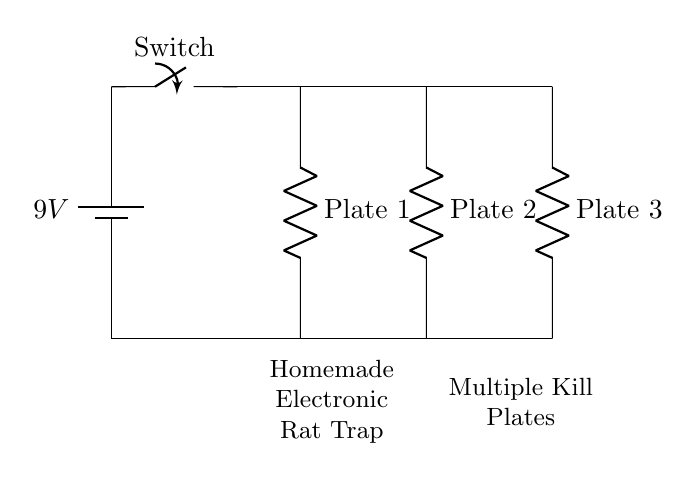What is the voltage of the power source? The voltage is labeled as 9V on the battery component in the circuit diagram, indicating the potential difference supplied to the circuit.
Answer: 9V How many kill plates are there in the circuit? There are three kill plates represented as resistors in the parallel configuration, which can be counted from left to right in the diagram.
Answer: Three What type of circuit is this? This circuit is a parallel circuit, as indicated by the configuration where multiple components (kill plates) are connected across the same two points of the power source, allowing for independent operation.
Answer: Parallel What is the role of the switch in this circuit? The switch controls the flow of current; if closed, it allows current to flow through the circuit, and if open, it stops the current flow, making it a critical component for controlling the trap.
Answer: Control If one kill plate fails, what happens to the others? In a parallel circuit, if one component (kill plate) fails, the others continue to operate as they are independent of each other. This is a defining feature of parallel configurations.
Answer: They continue to operate 